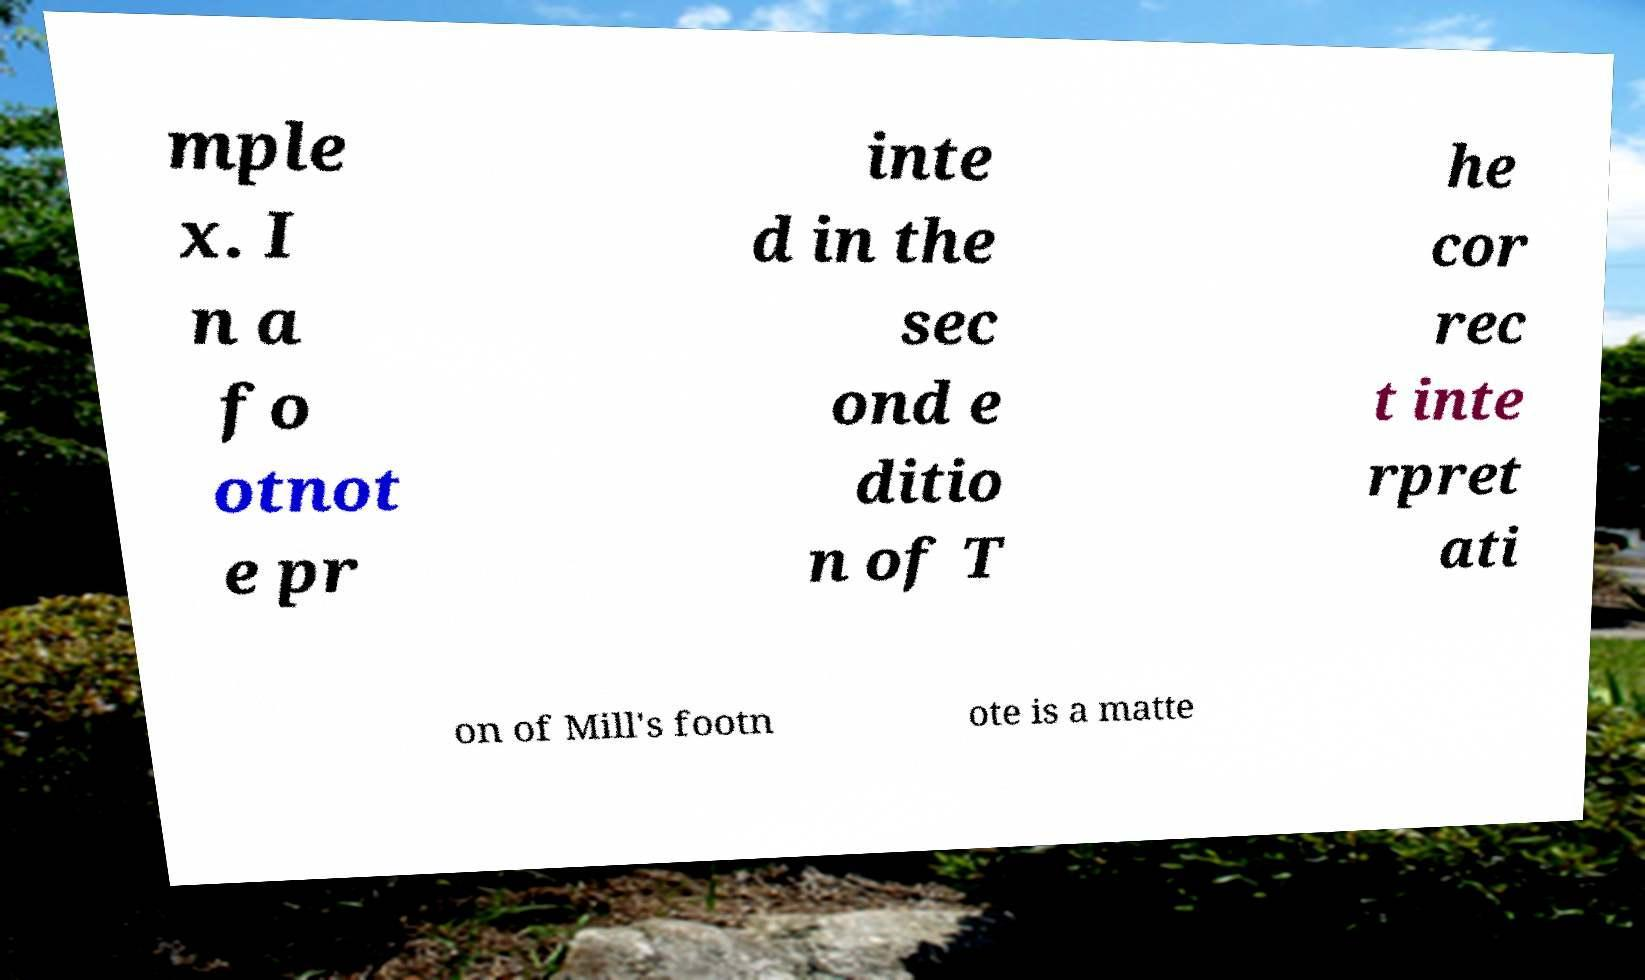What messages or text are displayed in this image? I need them in a readable, typed format. mple x. I n a fo otnot e pr inte d in the sec ond e ditio n of T he cor rec t inte rpret ati on of Mill's footn ote is a matte 